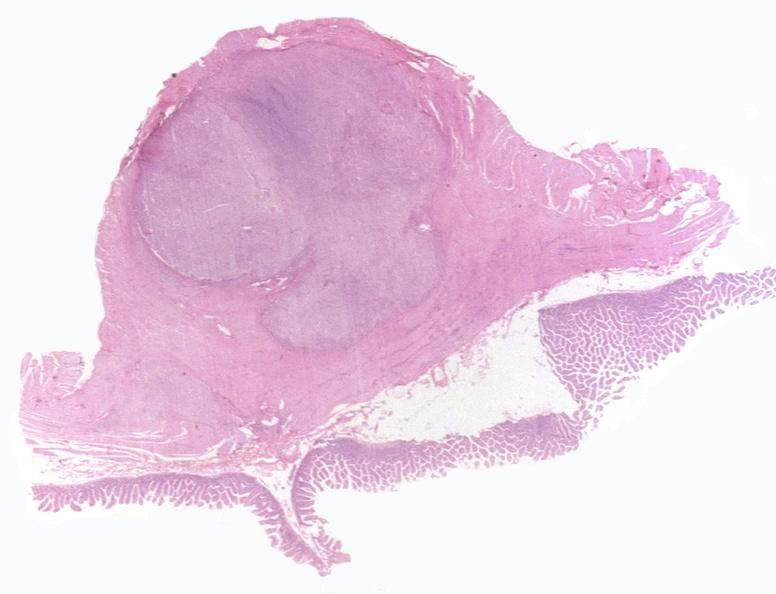what is present?
Answer the question using a single word or phrase. Gastrointestinal 